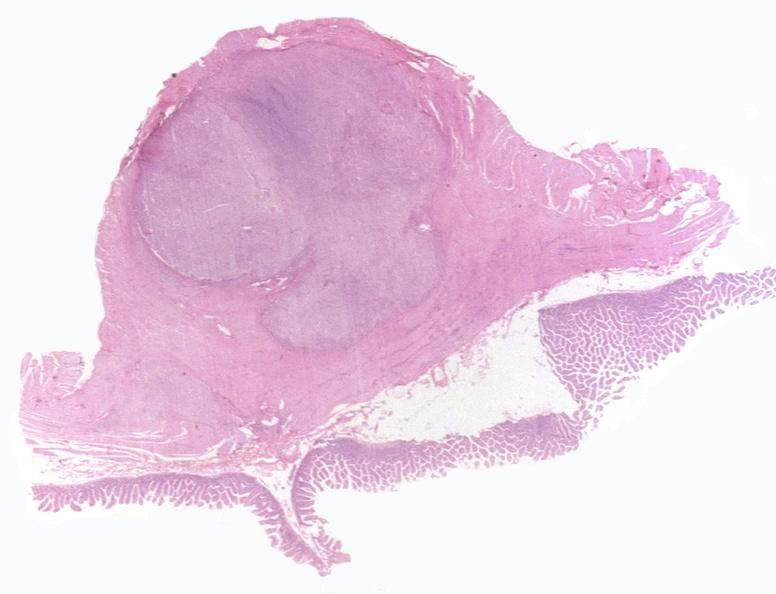what is present?
Answer the question using a single word or phrase. Gastrointestinal 